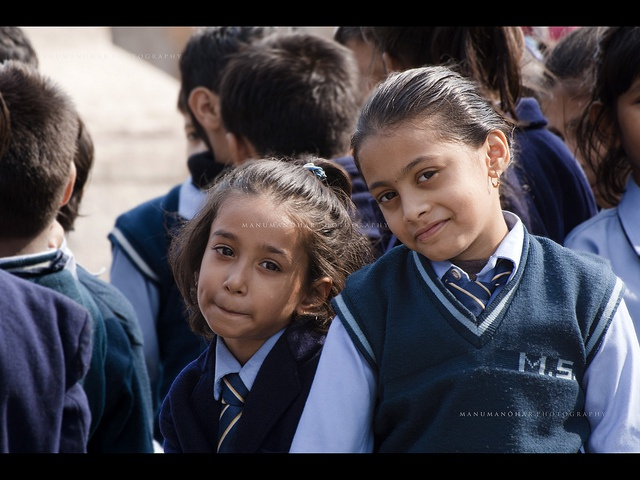Describe the objects in this image and their specific colors. I can see people in black, darkgray, gray, and navy tones, people in black, gray, and maroon tones, people in black, gray, and darkgray tones, people in black and gray tones, and people in black, gray, and navy tones in this image. 